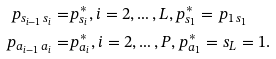Convert formula to latex. <formula><loc_0><loc_0><loc_500><loc_500>p _ { s _ { i - 1 } \, s _ { i } } = & p ^ { * } _ { s _ { i } } , i = 2 , \dots , L , p ^ { * } _ { s _ { 1 } } = p _ { 1 \, s _ { 1 } } \\ p _ { a _ { i - 1 } \, a _ { i } } = & p ^ { * } _ { a _ { i } } , i = 2 , \dots , P , p ^ { * } _ { a _ { 1 } } = s _ { L } = 1 .</formula> 